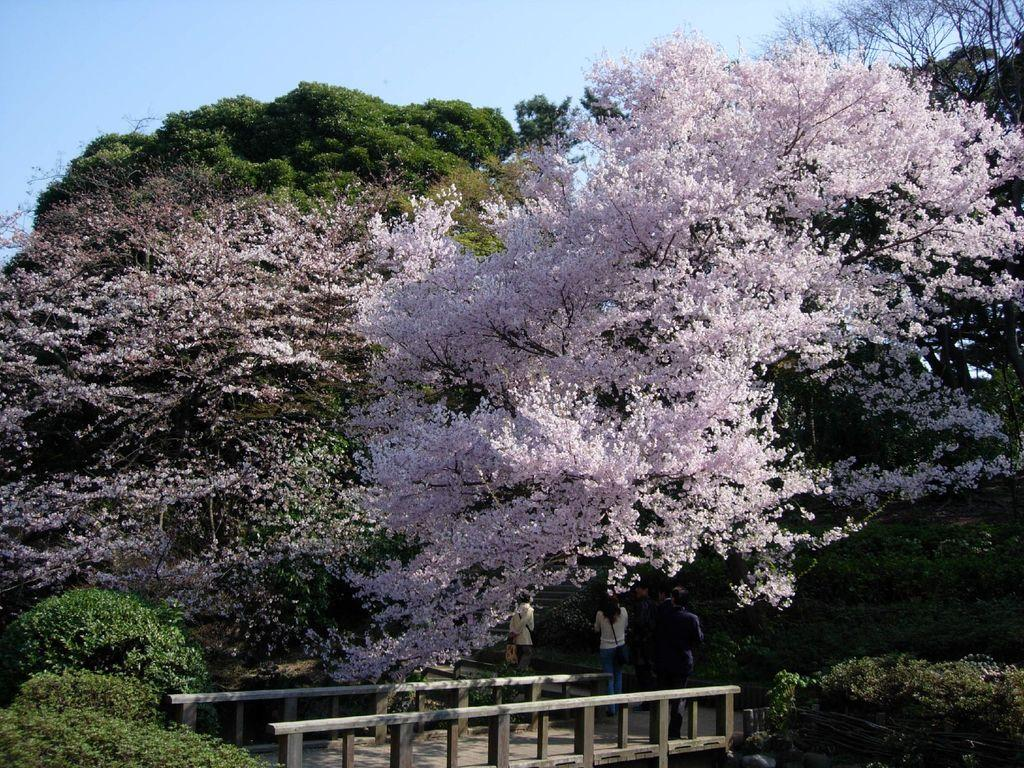What is located in the center of the image? There are trees in the center of the image. What can be observed about the trees? The trees have blossoms. What structure is at the bottom of the image? There is a bridge at the bottom of the image. What are the people in the image doing? People are standing on the bridge. What is visible at the top of the image? The sky is visible at the top of the image. Where is the zipper located in the image? There is no zipper present in the image. What type of edge can be seen on the trees in the image? The trees in the image have blossoms, but there is no mention of an edge. 